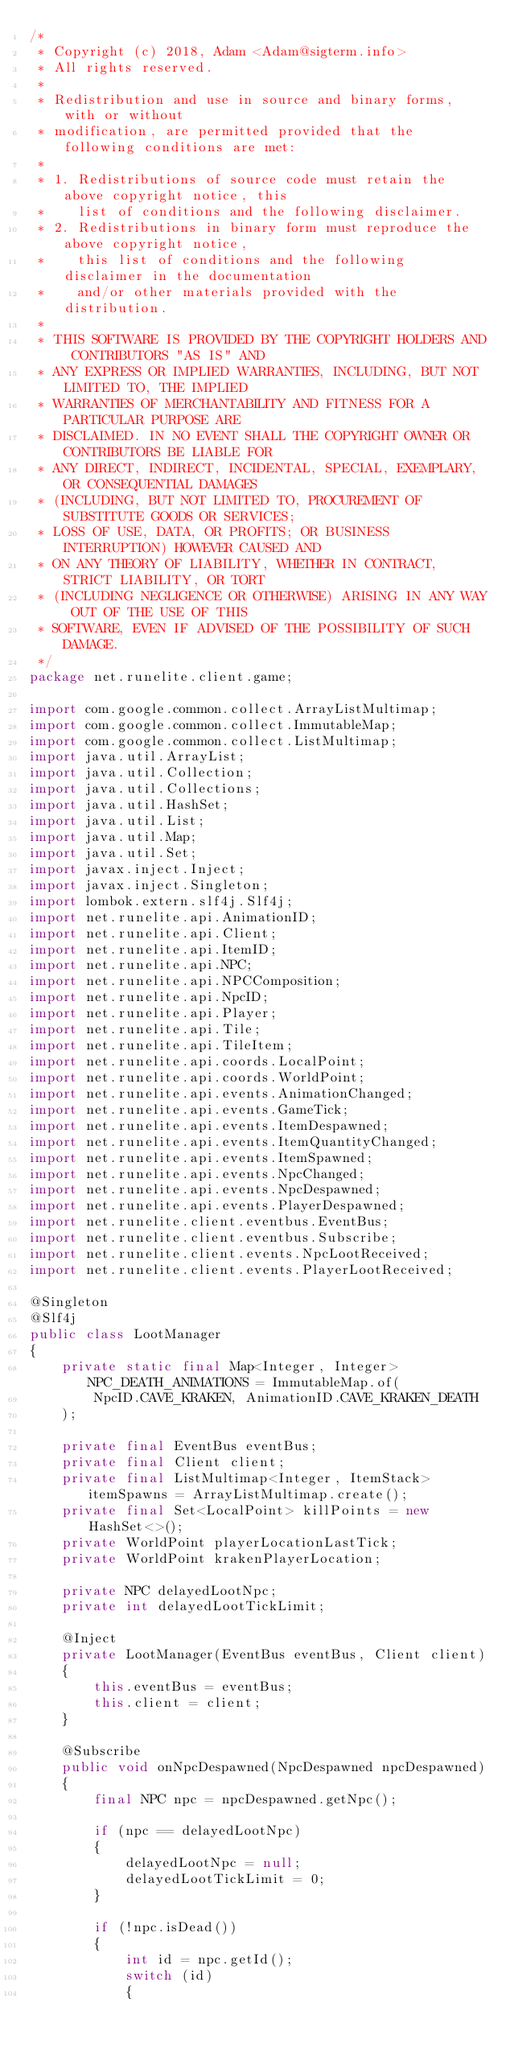<code> <loc_0><loc_0><loc_500><loc_500><_Java_>/*
 * Copyright (c) 2018, Adam <Adam@sigterm.info>
 * All rights reserved.
 *
 * Redistribution and use in source and binary forms, with or without
 * modification, are permitted provided that the following conditions are met:
 *
 * 1. Redistributions of source code must retain the above copyright notice, this
 *    list of conditions and the following disclaimer.
 * 2. Redistributions in binary form must reproduce the above copyright notice,
 *    this list of conditions and the following disclaimer in the documentation
 *    and/or other materials provided with the distribution.
 *
 * THIS SOFTWARE IS PROVIDED BY THE COPYRIGHT HOLDERS AND CONTRIBUTORS "AS IS" AND
 * ANY EXPRESS OR IMPLIED WARRANTIES, INCLUDING, BUT NOT LIMITED TO, THE IMPLIED
 * WARRANTIES OF MERCHANTABILITY AND FITNESS FOR A PARTICULAR PURPOSE ARE
 * DISCLAIMED. IN NO EVENT SHALL THE COPYRIGHT OWNER OR CONTRIBUTORS BE LIABLE FOR
 * ANY DIRECT, INDIRECT, INCIDENTAL, SPECIAL, EXEMPLARY, OR CONSEQUENTIAL DAMAGES
 * (INCLUDING, BUT NOT LIMITED TO, PROCUREMENT OF SUBSTITUTE GOODS OR SERVICES;
 * LOSS OF USE, DATA, OR PROFITS; OR BUSINESS INTERRUPTION) HOWEVER CAUSED AND
 * ON ANY THEORY OF LIABILITY, WHETHER IN CONTRACT, STRICT LIABILITY, OR TORT
 * (INCLUDING NEGLIGENCE OR OTHERWISE) ARISING IN ANY WAY OUT OF THE USE OF THIS
 * SOFTWARE, EVEN IF ADVISED OF THE POSSIBILITY OF SUCH DAMAGE.
 */
package net.runelite.client.game;

import com.google.common.collect.ArrayListMultimap;
import com.google.common.collect.ImmutableMap;
import com.google.common.collect.ListMultimap;
import java.util.ArrayList;
import java.util.Collection;
import java.util.Collections;
import java.util.HashSet;
import java.util.List;
import java.util.Map;
import java.util.Set;
import javax.inject.Inject;
import javax.inject.Singleton;
import lombok.extern.slf4j.Slf4j;
import net.runelite.api.AnimationID;
import net.runelite.api.Client;
import net.runelite.api.ItemID;
import net.runelite.api.NPC;
import net.runelite.api.NPCComposition;
import net.runelite.api.NpcID;
import net.runelite.api.Player;
import net.runelite.api.Tile;
import net.runelite.api.TileItem;
import net.runelite.api.coords.LocalPoint;
import net.runelite.api.coords.WorldPoint;
import net.runelite.api.events.AnimationChanged;
import net.runelite.api.events.GameTick;
import net.runelite.api.events.ItemDespawned;
import net.runelite.api.events.ItemQuantityChanged;
import net.runelite.api.events.ItemSpawned;
import net.runelite.api.events.NpcChanged;
import net.runelite.api.events.NpcDespawned;
import net.runelite.api.events.PlayerDespawned;
import net.runelite.client.eventbus.EventBus;
import net.runelite.client.eventbus.Subscribe;
import net.runelite.client.events.NpcLootReceived;
import net.runelite.client.events.PlayerLootReceived;

@Singleton
@Slf4j
public class LootManager
{
	private static final Map<Integer, Integer> NPC_DEATH_ANIMATIONS = ImmutableMap.of(
		NpcID.CAVE_KRAKEN, AnimationID.CAVE_KRAKEN_DEATH
	);

	private final EventBus eventBus;
	private final Client client;
	private final ListMultimap<Integer, ItemStack> itemSpawns = ArrayListMultimap.create();
	private final Set<LocalPoint> killPoints = new HashSet<>();
	private WorldPoint playerLocationLastTick;
	private WorldPoint krakenPlayerLocation;

	private NPC delayedLootNpc;
	private int delayedLootTickLimit;

	@Inject
	private LootManager(EventBus eventBus, Client client)
	{
		this.eventBus = eventBus;
		this.client = client;
	}

	@Subscribe
	public void onNpcDespawned(NpcDespawned npcDespawned)
	{
		final NPC npc = npcDespawned.getNpc();

		if (npc == delayedLootNpc)
		{
			delayedLootNpc = null;
			delayedLootTickLimit = 0;
		}

		if (!npc.isDead())
		{
			int id = npc.getId();
			switch (id)
			{</code> 